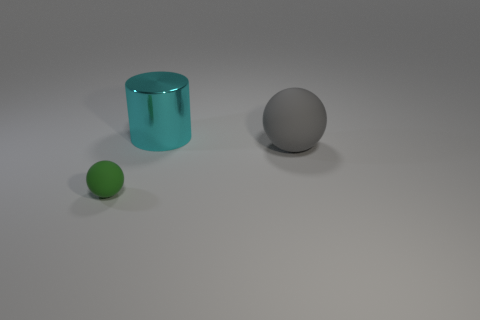Add 1 gray matte balls. How many objects exist? 4 Subtract all spheres. How many objects are left? 1 Subtract 0 cyan blocks. How many objects are left? 3 Subtract all cyan things. Subtract all cyan things. How many objects are left? 1 Add 3 gray objects. How many gray objects are left? 4 Add 3 big brown balls. How many big brown balls exist? 3 